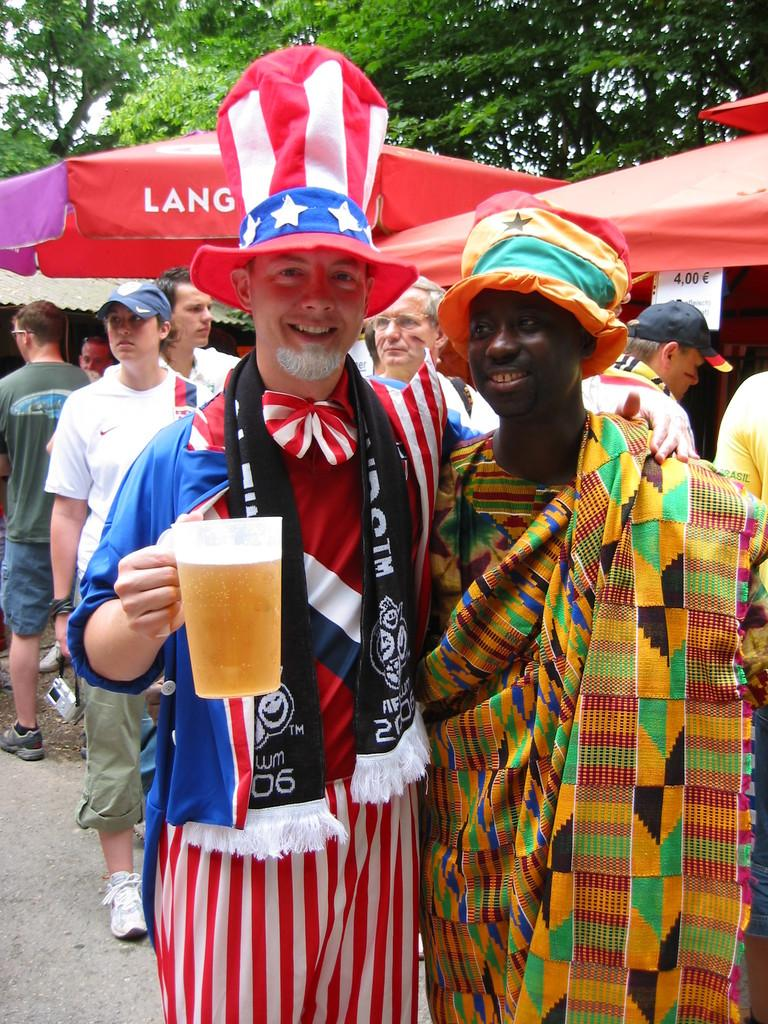Provide a one-sentence caption for the provided image. a man wearing an uncle sam costume with the year 2006 on his scarf. 